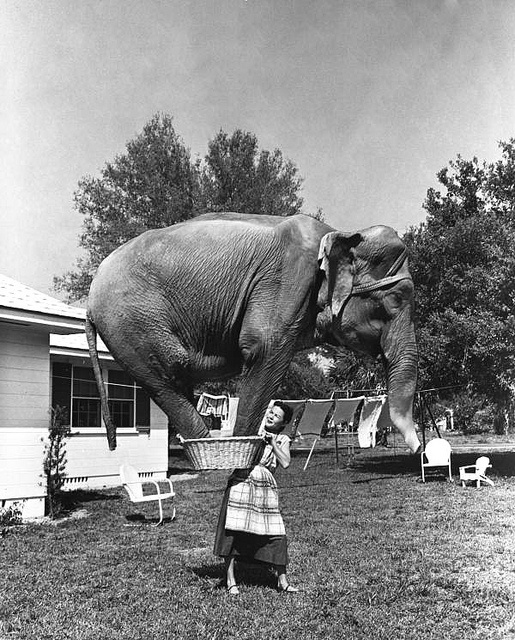Describe the objects in this image and their specific colors. I can see elephant in white, gray, black, darkgray, and lightgray tones, people in white, black, lightgray, gray, and darkgray tones, chair in white, gray, darkgray, and black tones, chair in white, black, darkgray, and gray tones, and chair in white, black, gray, and darkgray tones in this image. 